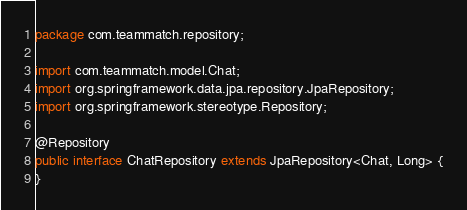Convert code to text. <code><loc_0><loc_0><loc_500><loc_500><_Java_>package com.teammatch.repository;

import com.teammatch.model.Chat;
import org.springframework.data.jpa.repository.JpaRepository;
import org.springframework.stereotype.Repository;

@Repository
public interface ChatRepository extends JpaRepository<Chat, Long> {
}
</code> 